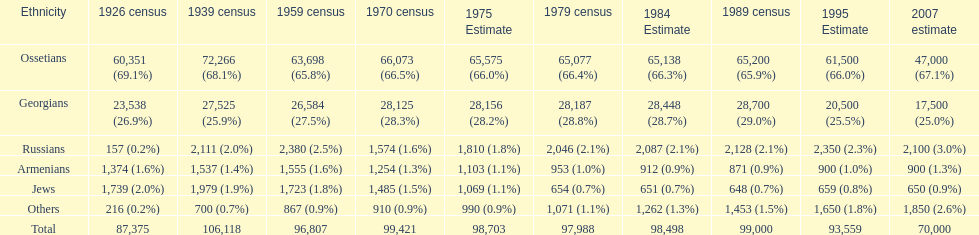How many ethnicities were below 1,000 people in 2007? 2. 